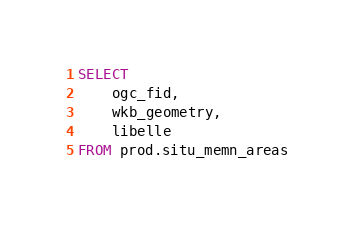Convert code to text. <code><loc_0><loc_0><loc_500><loc_500><_SQL_>SELECT 
    ogc_fid,
    wkb_geometry,
    libelle
FROM prod.situ_memn_areas</code> 